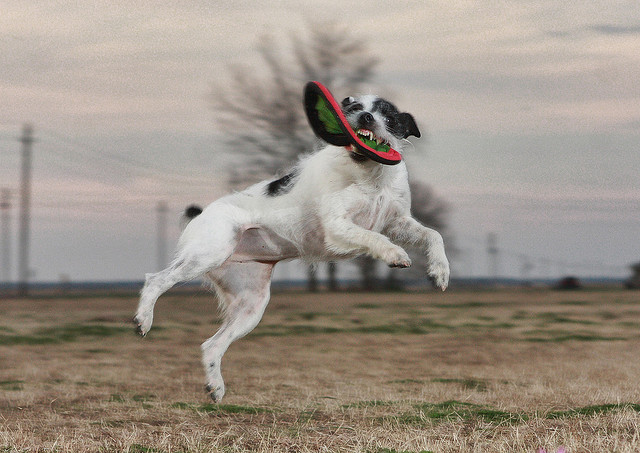How many dogs? There is one energetic dog in the image, captured in mid-air with a frisbee in its mouth. 